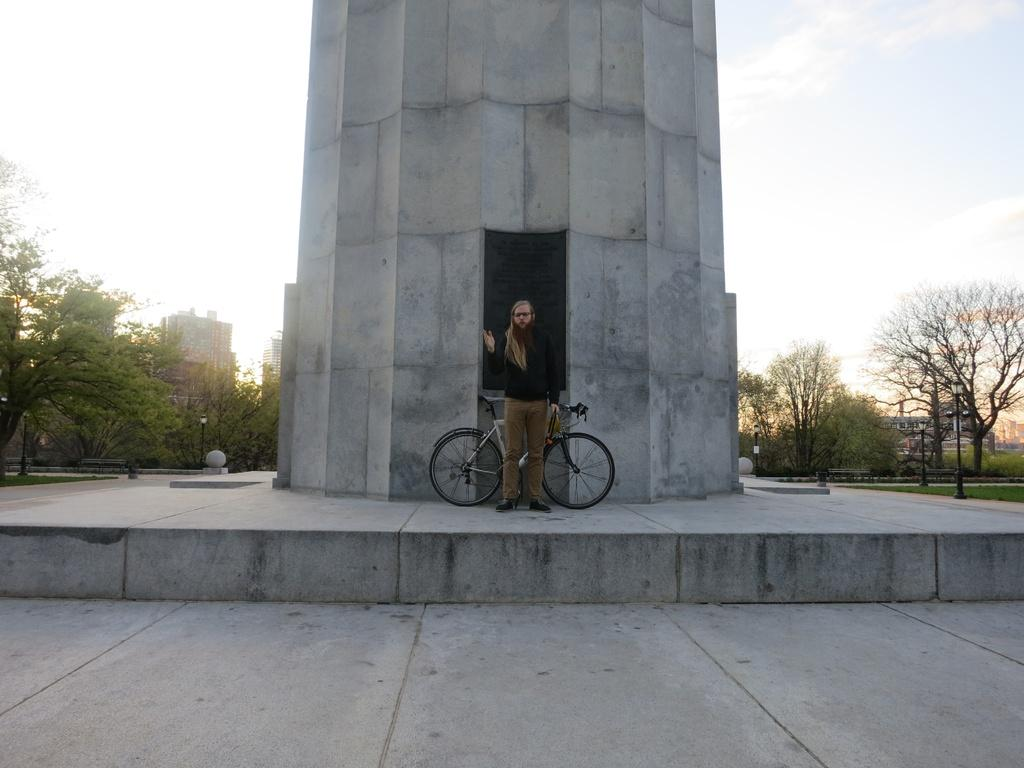What mode of transportation can be seen in the image? There is a cycle in the image. Who is present in the image? There is a person standing in the image. What type of structure is visible in the image? There is a tower in the image. What type of vegetation is present in the image? There are trees and grass in the image. What type of urban infrastructure can be seen in the image? There are street poles in the image. What type of buildings are visible in the image? There are buildings in the image. What is the condition of the sky in the image? The sky is visible in the image and appears cloudy. What channel is the person watching on the cycle in the image? There is no channel or television present in the image; it features a person standing next to a cycle. How many cups are visible on the cycle in the image? There are no cups visible on the cycle in the image. 